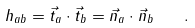Convert formula to latex. <formula><loc_0><loc_0><loc_500><loc_500>h _ { a b } = \vec { t } _ { a } \cdot \vec { t } _ { b } = \vec { n } _ { a } \cdot \vec { n } _ { b } \quad .</formula> 